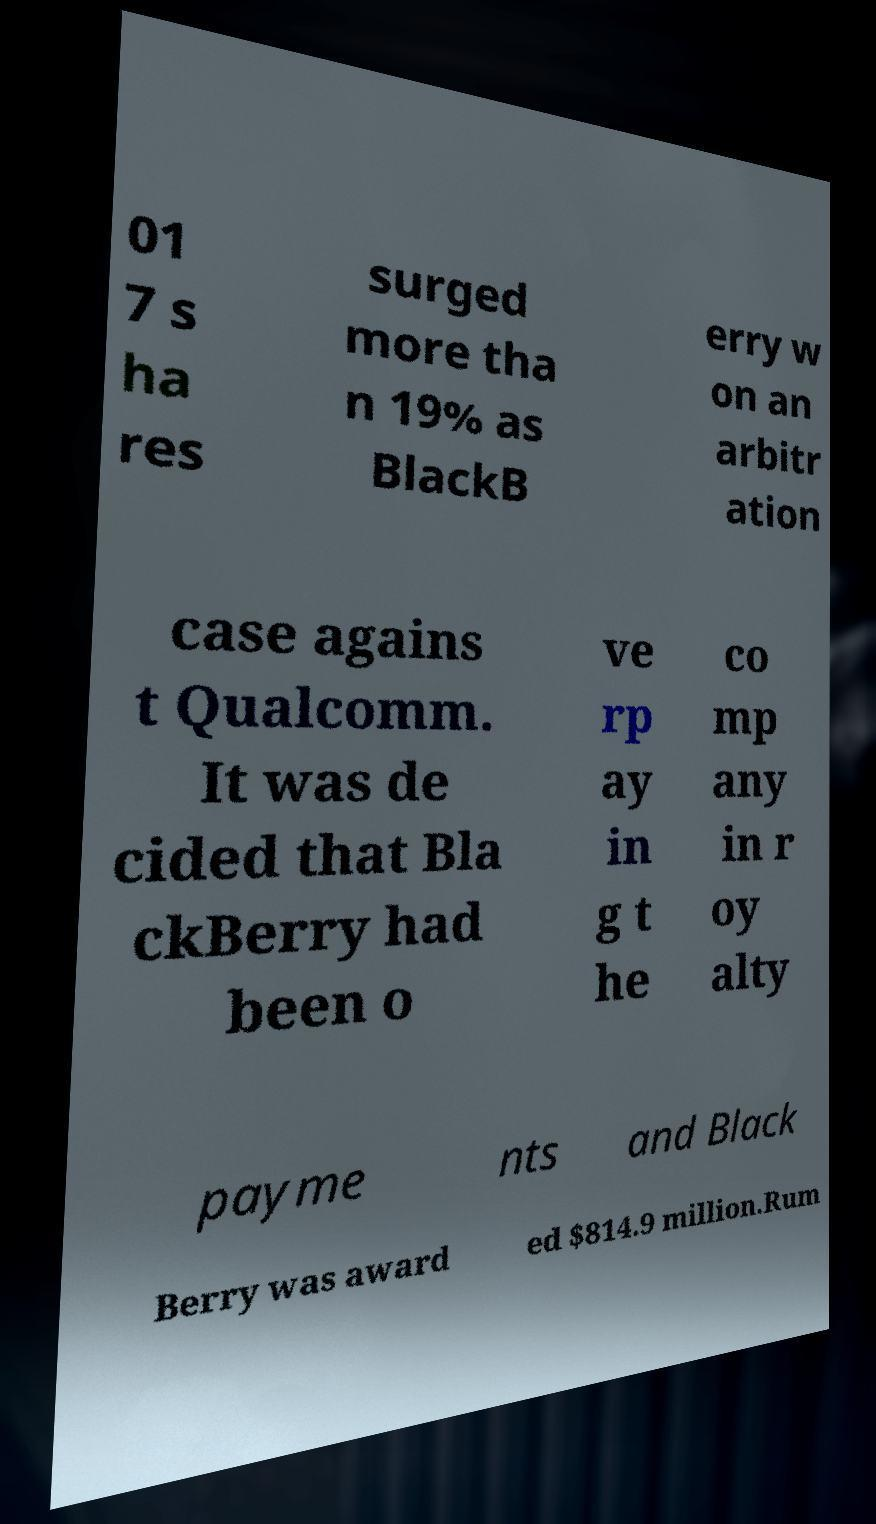For documentation purposes, I need the text within this image transcribed. Could you provide that? 01 7 s ha res surged more tha n 19% as BlackB erry w on an arbitr ation case agains t Qualcomm. It was de cided that Bla ckBerry had been o ve rp ay in g t he co mp any in r oy alty payme nts and Black Berry was award ed $814.9 million.Rum 